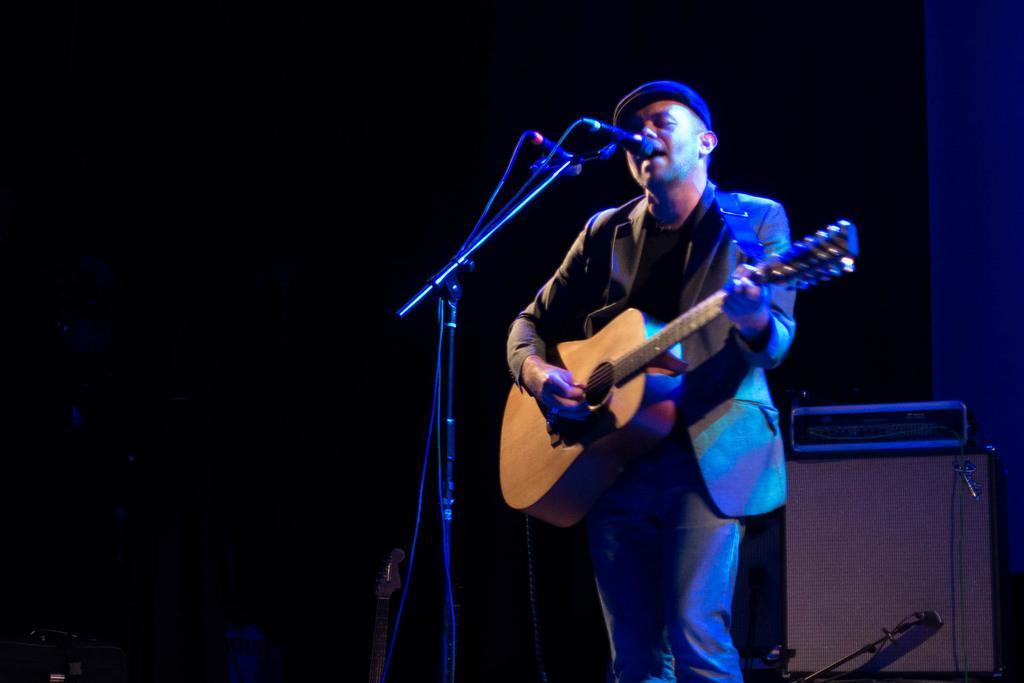Please provide a concise description of this image. In this image in the middle there is man he wear suit, hat and trouser he is playing guitar. In the middle there is a mic and mic stand. In the background there is a guitar, table. 